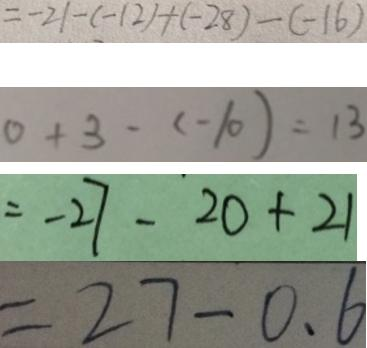Convert formula to latex. <formula><loc_0><loc_0><loc_500><loc_500>= - 2 1 - ( - 1 2 ) + ( - 2 8 ) - ( - 1 6 ) 
 0 + 3 - ( - 1 0 ) = 1 3 
 = - 2 7 - 2 0 + 2 1 
 = 2 7 - 0 . 6</formula> 